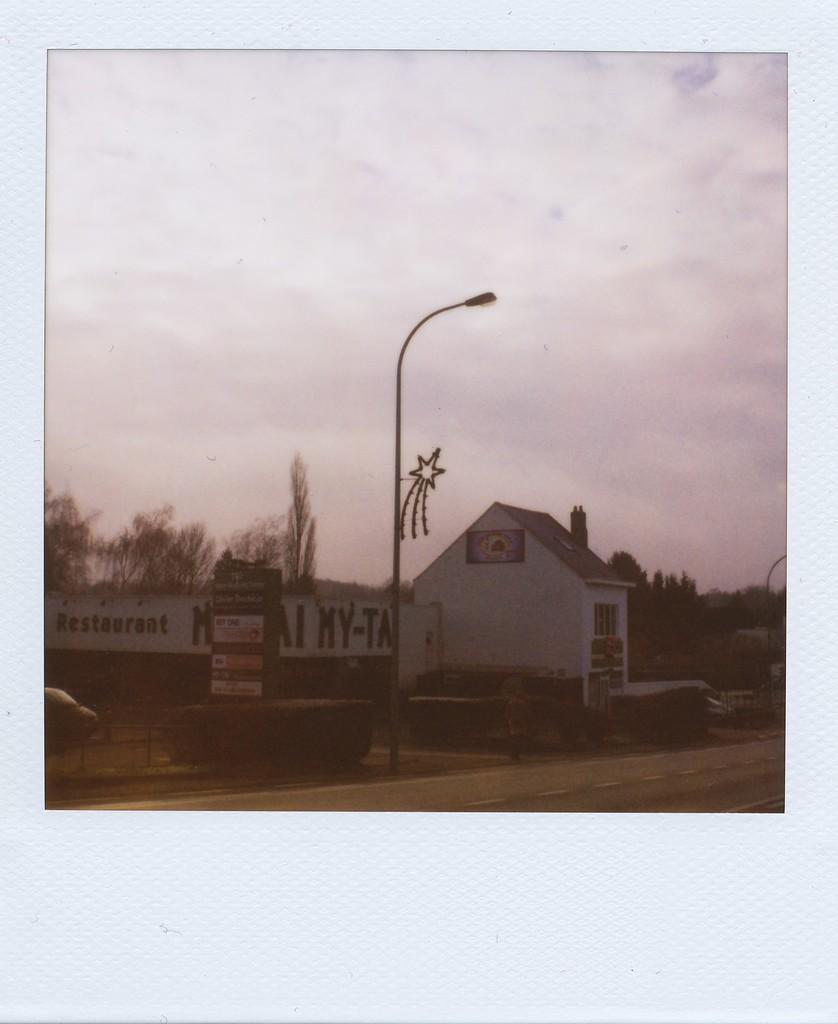Please provide a concise description of this image. This image consists of a small house in the middle. There is a light in the middle. There are trees in the middle. There is sky at the top. 